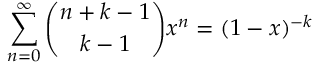<formula> <loc_0><loc_0><loc_500><loc_500>\sum _ { n = 0 } ^ { \infty } \binom { n + k - 1 } { k - 1 } x ^ { n } = ( 1 - x ) ^ { - k }</formula> 